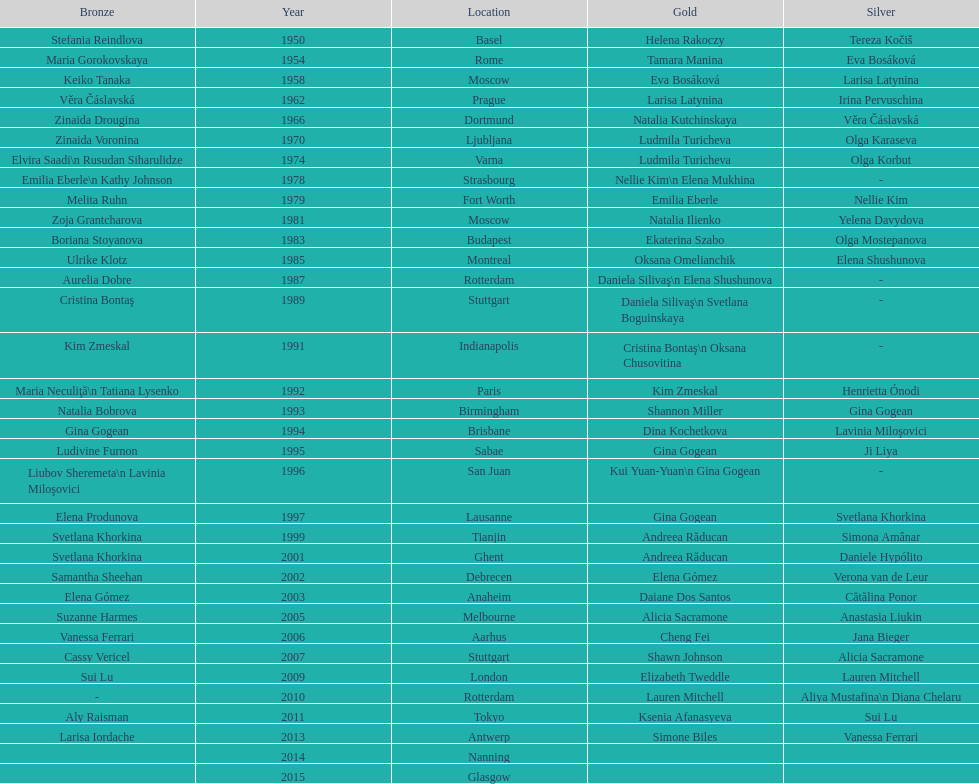Where did the world artistic gymnastics take place before san juan? Sabae. 